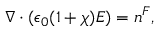Convert formula to latex. <formula><loc_0><loc_0><loc_500><loc_500>\nabla \cdot ( \epsilon _ { 0 } ( 1 + \chi ) E ) = n ^ { F } ,</formula> 